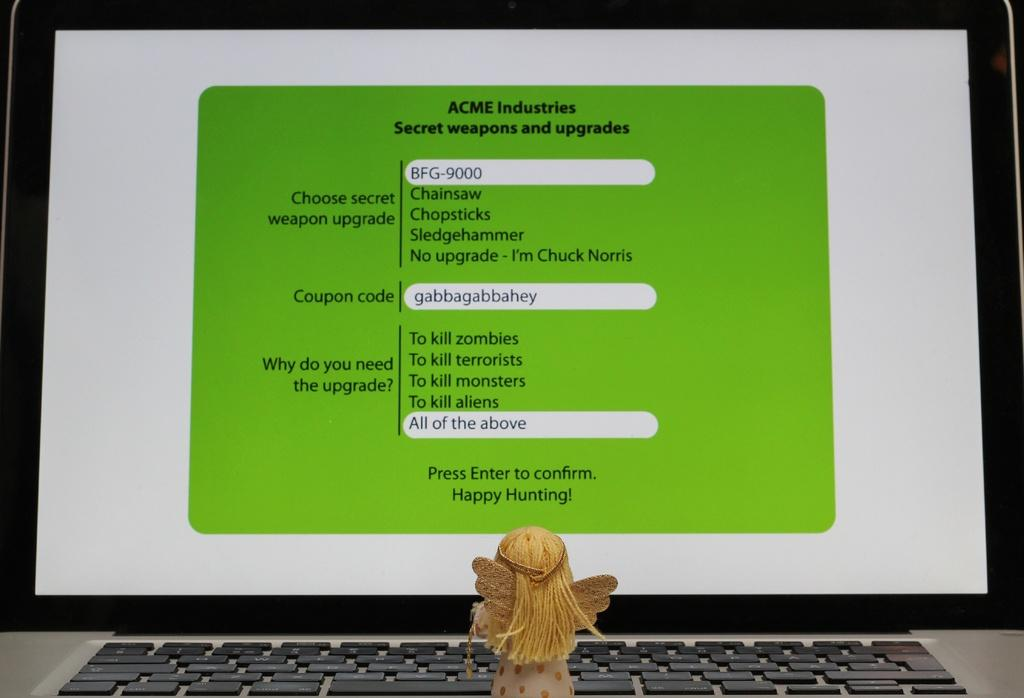<image>
Write a terse but informative summary of the picture. a menu of options to upgrade ACME secret weapons. 